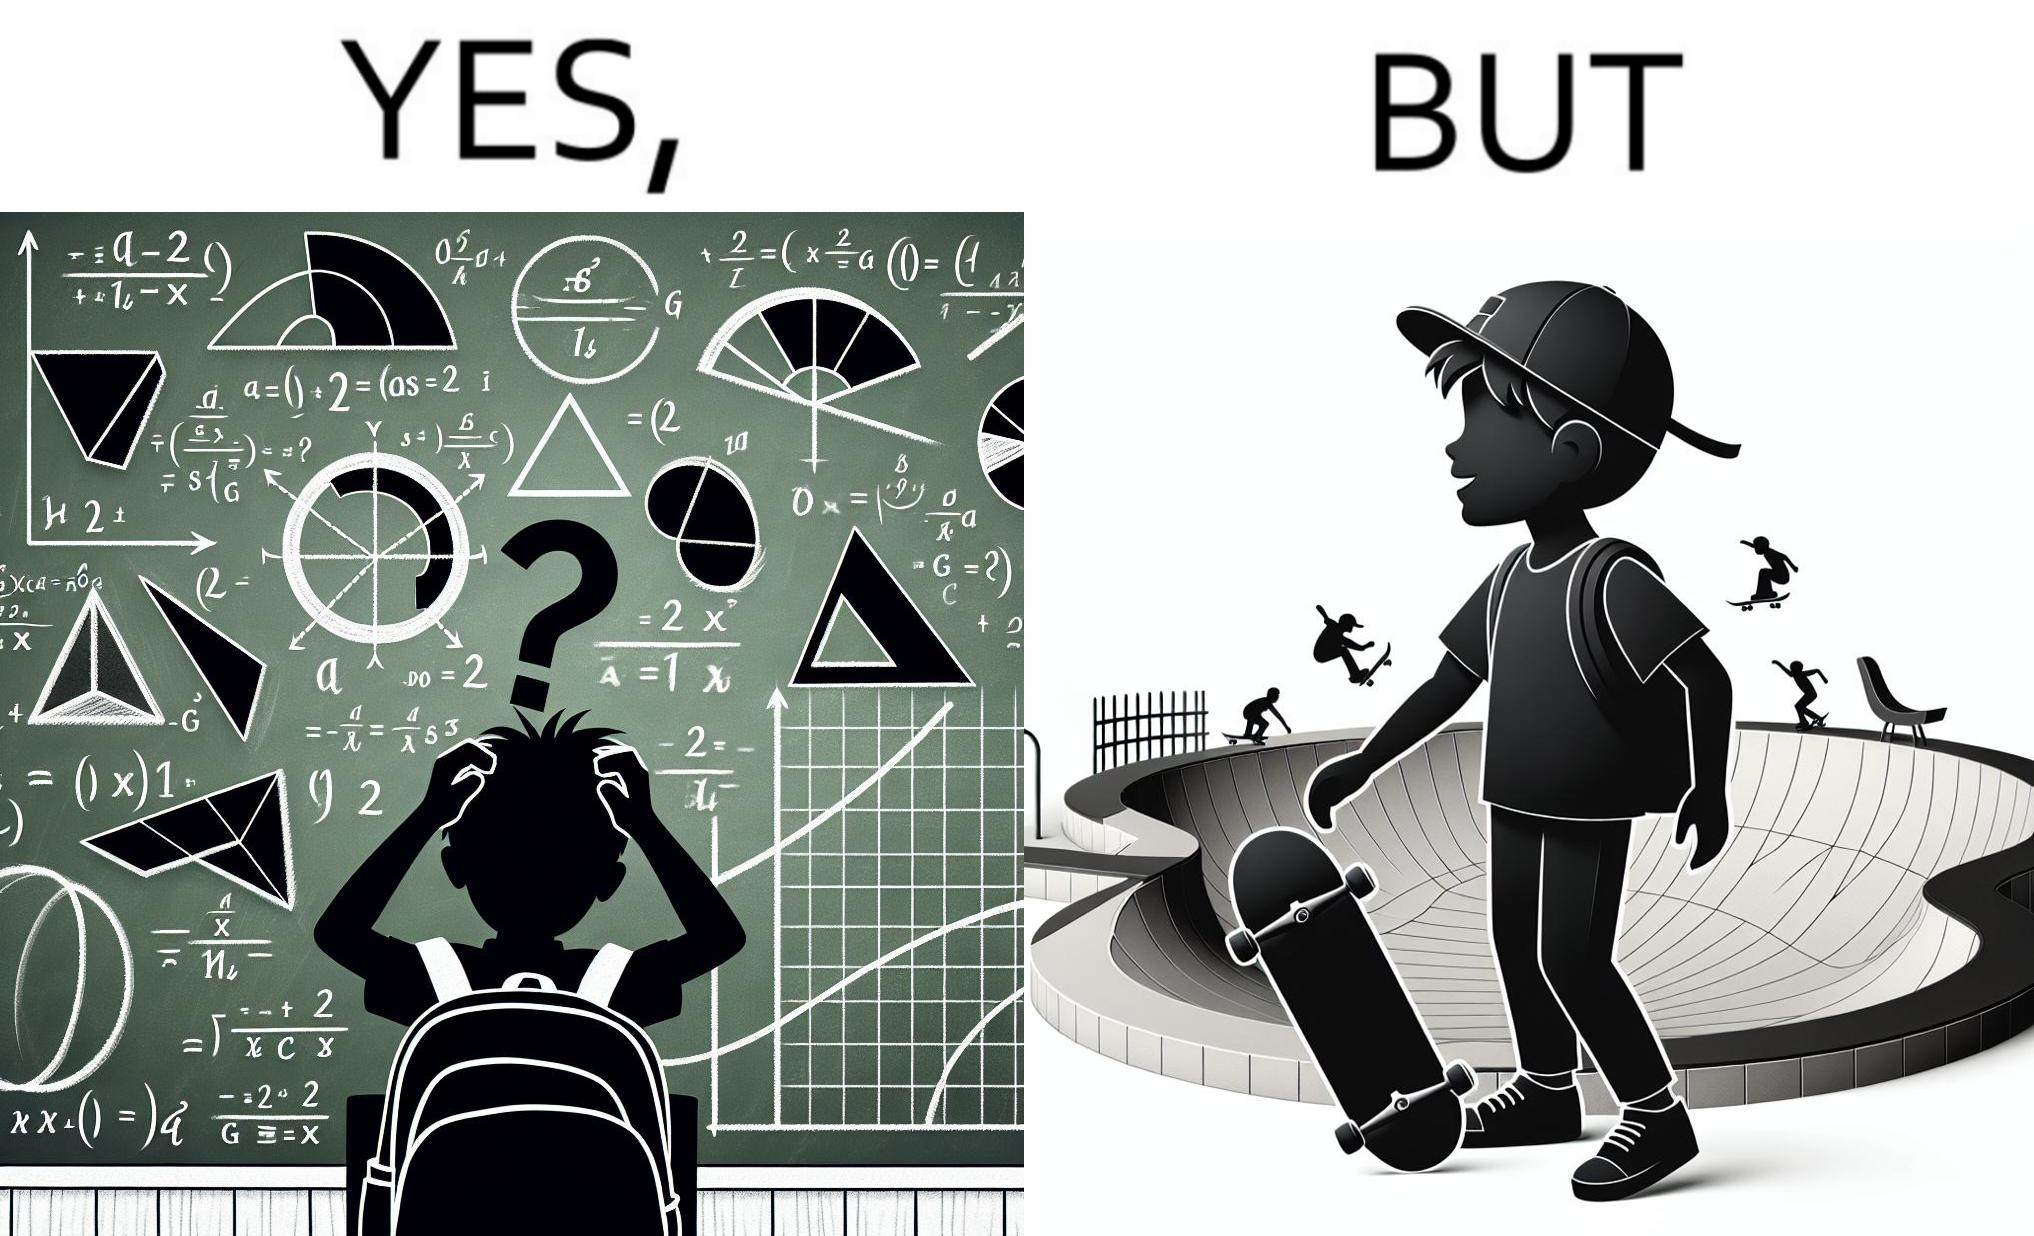Describe the content of this image. The image is ironical beaucse while the boy does not enjoy studying mathematics and different geometric shapes like semi circle and trapezoid and graphs of trigonometric equations like that of a sine wave, he enjoys skateboarding on surfaces and bowls that are built based on the said geometric shapes and graphs of trigonometric equations. 